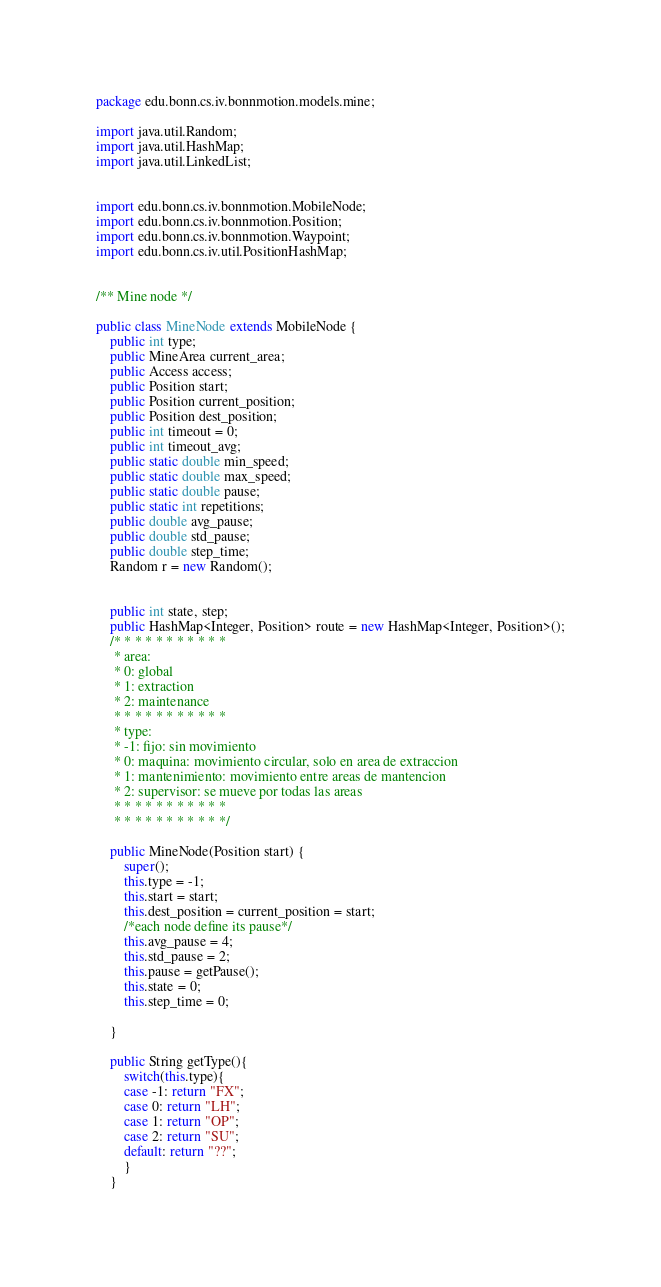Convert code to text. <code><loc_0><loc_0><loc_500><loc_500><_Java_>
package edu.bonn.cs.iv.bonnmotion.models.mine;

import java.util.Random;
import java.util.HashMap;
import java.util.LinkedList;


import edu.bonn.cs.iv.bonnmotion.MobileNode;
import edu.bonn.cs.iv.bonnmotion.Position;
import edu.bonn.cs.iv.bonnmotion.Waypoint;
import edu.bonn.cs.iv.util.PositionHashMap;


/** Mine node */

public class MineNode extends MobileNode {
	public int type;
	public MineArea current_area;
	public Access access;
	public Position start;
	public Position current_position;
	public Position dest_position;
	public int timeout = 0;
	public int timeout_avg;
	public static double min_speed;
	public static double max_speed;
	public static double pause;
	public static int repetitions;
	public double avg_pause;
	public double std_pause;
	public double step_time;
	Random r = new Random();
	
	
	public int state, step;
	public HashMap<Integer, Position> route = new HashMap<Integer, Position>();
	/* * * * * * * * * * *
	 * area:
	 * 0: global 
	 * 1: extraction
	 * 2: maintenance
	 * * * * * * * * * * *
	 * type:
	 * -1: fijo: sin movimiento
	 * 0: maquina: movimiento circular, solo en area de extraccion
	 * 1: mantenimiento: movimiento entre areas de mantencion
	 * 2: supervisor: se mueve por todas las areas
	 * * * * * * * * * * *
	 * * * * * * * * * * */

	public MineNode(Position start) {
		super();
		this.type = -1;
		this.start = start;
		this.dest_position = current_position = start;
		/*each node define its pause*/
		this.avg_pause = 4;
		this.std_pause = 2;
		this.pause = getPause();
		this.state = 0;
		this.step_time = 0;

	}
	
	public String getType(){
		switch(this.type){
		case -1: return "FX";
		case 0: return "LH";
		case 1: return "OP";
		case 2: return "SU";
		default: return "??";
		}
	}</code> 